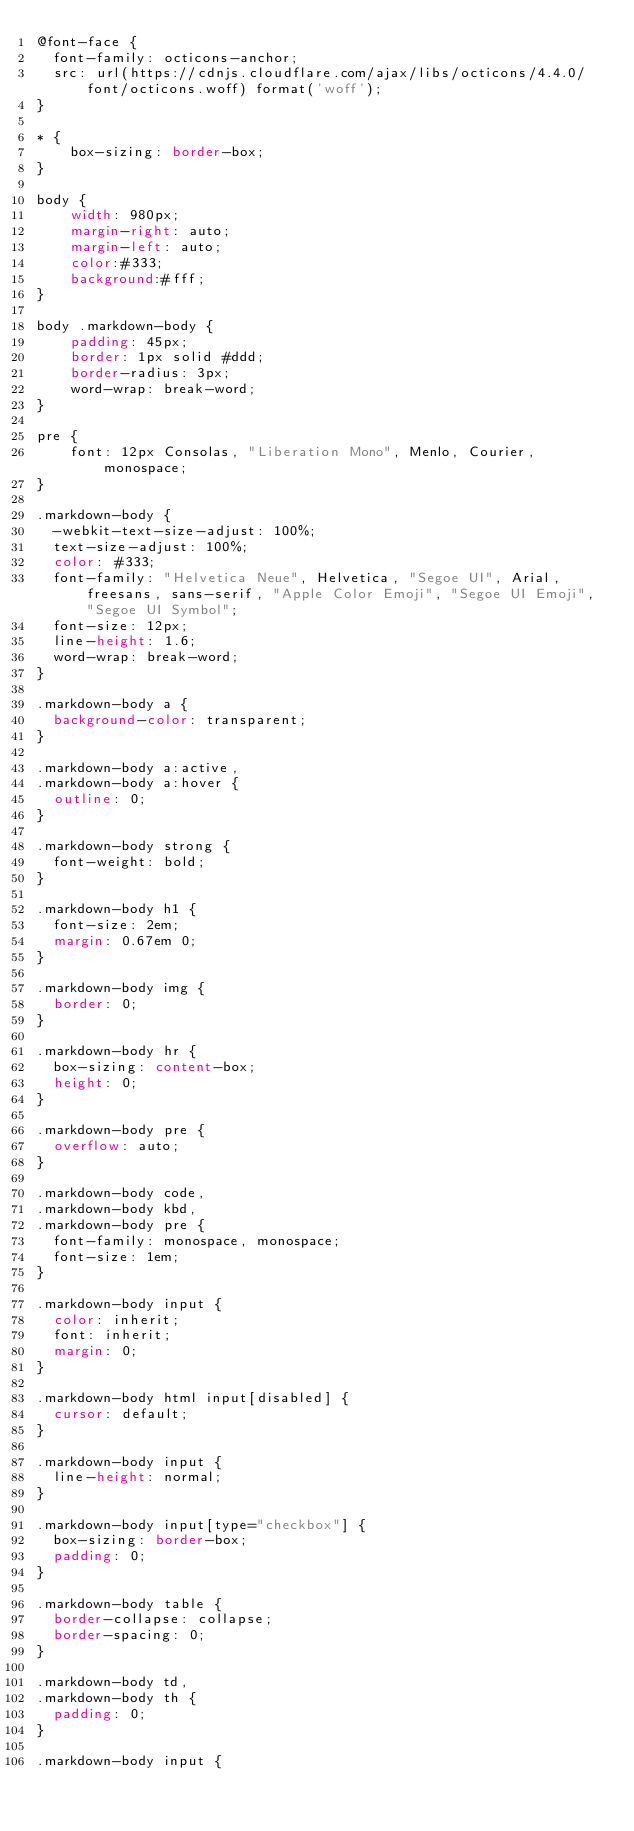Convert code to text. <code><loc_0><loc_0><loc_500><loc_500><_CSS_>@font-face {
  font-family: octicons-anchor;
  src: url(https://cdnjs.cloudflare.com/ajax/libs/octicons/4.4.0/font/octicons.woff) format('woff');
}

* {
    box-sizing: border-box;
}

body {
    width: 980px;
    margin-right: auto;
    margin-left: auto;
    color:#333;
    background:#fff;
}

body .markdown-body {
    padding: 45px;
    border: 1px solid #ddd;
    border-radius: 3px;
    word-wrap: break-word;
}

pre {
    font: 12px Consolas, "Liberation Mono", Menlo, Courier, monospace;
}

.markdown-body {
  -webkit-text-size-adjust: 100%;
  text-size-adjust: 100%;
  color: #333;
  font-family: "Helvetica Neue", Helvetica, "Segoe UI", Arial, freesans, sans-serif, "Apple Color Emoji", "Segoe UI Emoji", "Segoe UI Symbol";
  font-size: 12px;
  line-height: 1.6;
  word-wrap: break-word;
}

.markdown-body a {
  background-color: transparent;
}

.markdown-body a:active,
.markdown-body a:hover {
  outline: 0;
}

.markdown-body strong {
  font-weight: bold;
}

.markdown-body h1 {
  font-size: 2em;
  margin: 0.67em 0;
}

.markdown-body img {
  border: 0;
}

.markdown-body hr {
  box-sizing: content-box;
  height: 0;
}

.markdown-body pre {
  overflow: auto;
}

.markdown-body code,
.markdown-body kbd,
.markdown-body pre {
  font-family: monospace, monospace;
  font-size: 1em;
}

.markdown-body input {
  color: inherit;
  font: inherit;
  margin: 0;
}

.markdown-body html input[disabled] {
  cursor: default;
}

.markdown-body input {
  line-height: normal;
}

.markdown-body input[type="checkbox"] {
  box-sizing: border-box;
  padding: 0;
}

.markdown-body table {
  border-collapse: collapse;
  border-spacing: 0;
}

.markdown-body td,
.markdown-body th {
  padding: 0;
}

.markdown-body input {</code> 